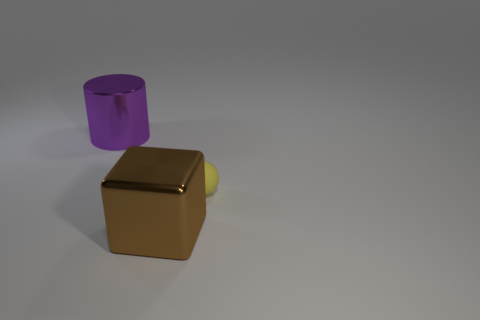Is there something that could enhance the visual appeal of this scene? To enhance the visual appeal, one might consider introducing additional elements to create a sense of scale or purpose, such as placing these objects on a textured surface or incorporating them into a setting with background elements. Incorporating a variety of colors that complement or contrast with the existing palette could also add visual interest. Could color theory help in choosing those colors? Absolutely! Using color theory, one could choose complementary colors to the purple and brown hues, such as soft yellows or greens, to create a dynamic and harmonious visual experience. Analogous colors, like deep reds or blues, could also work well to create a more cohesive scene with subtle contrast. 